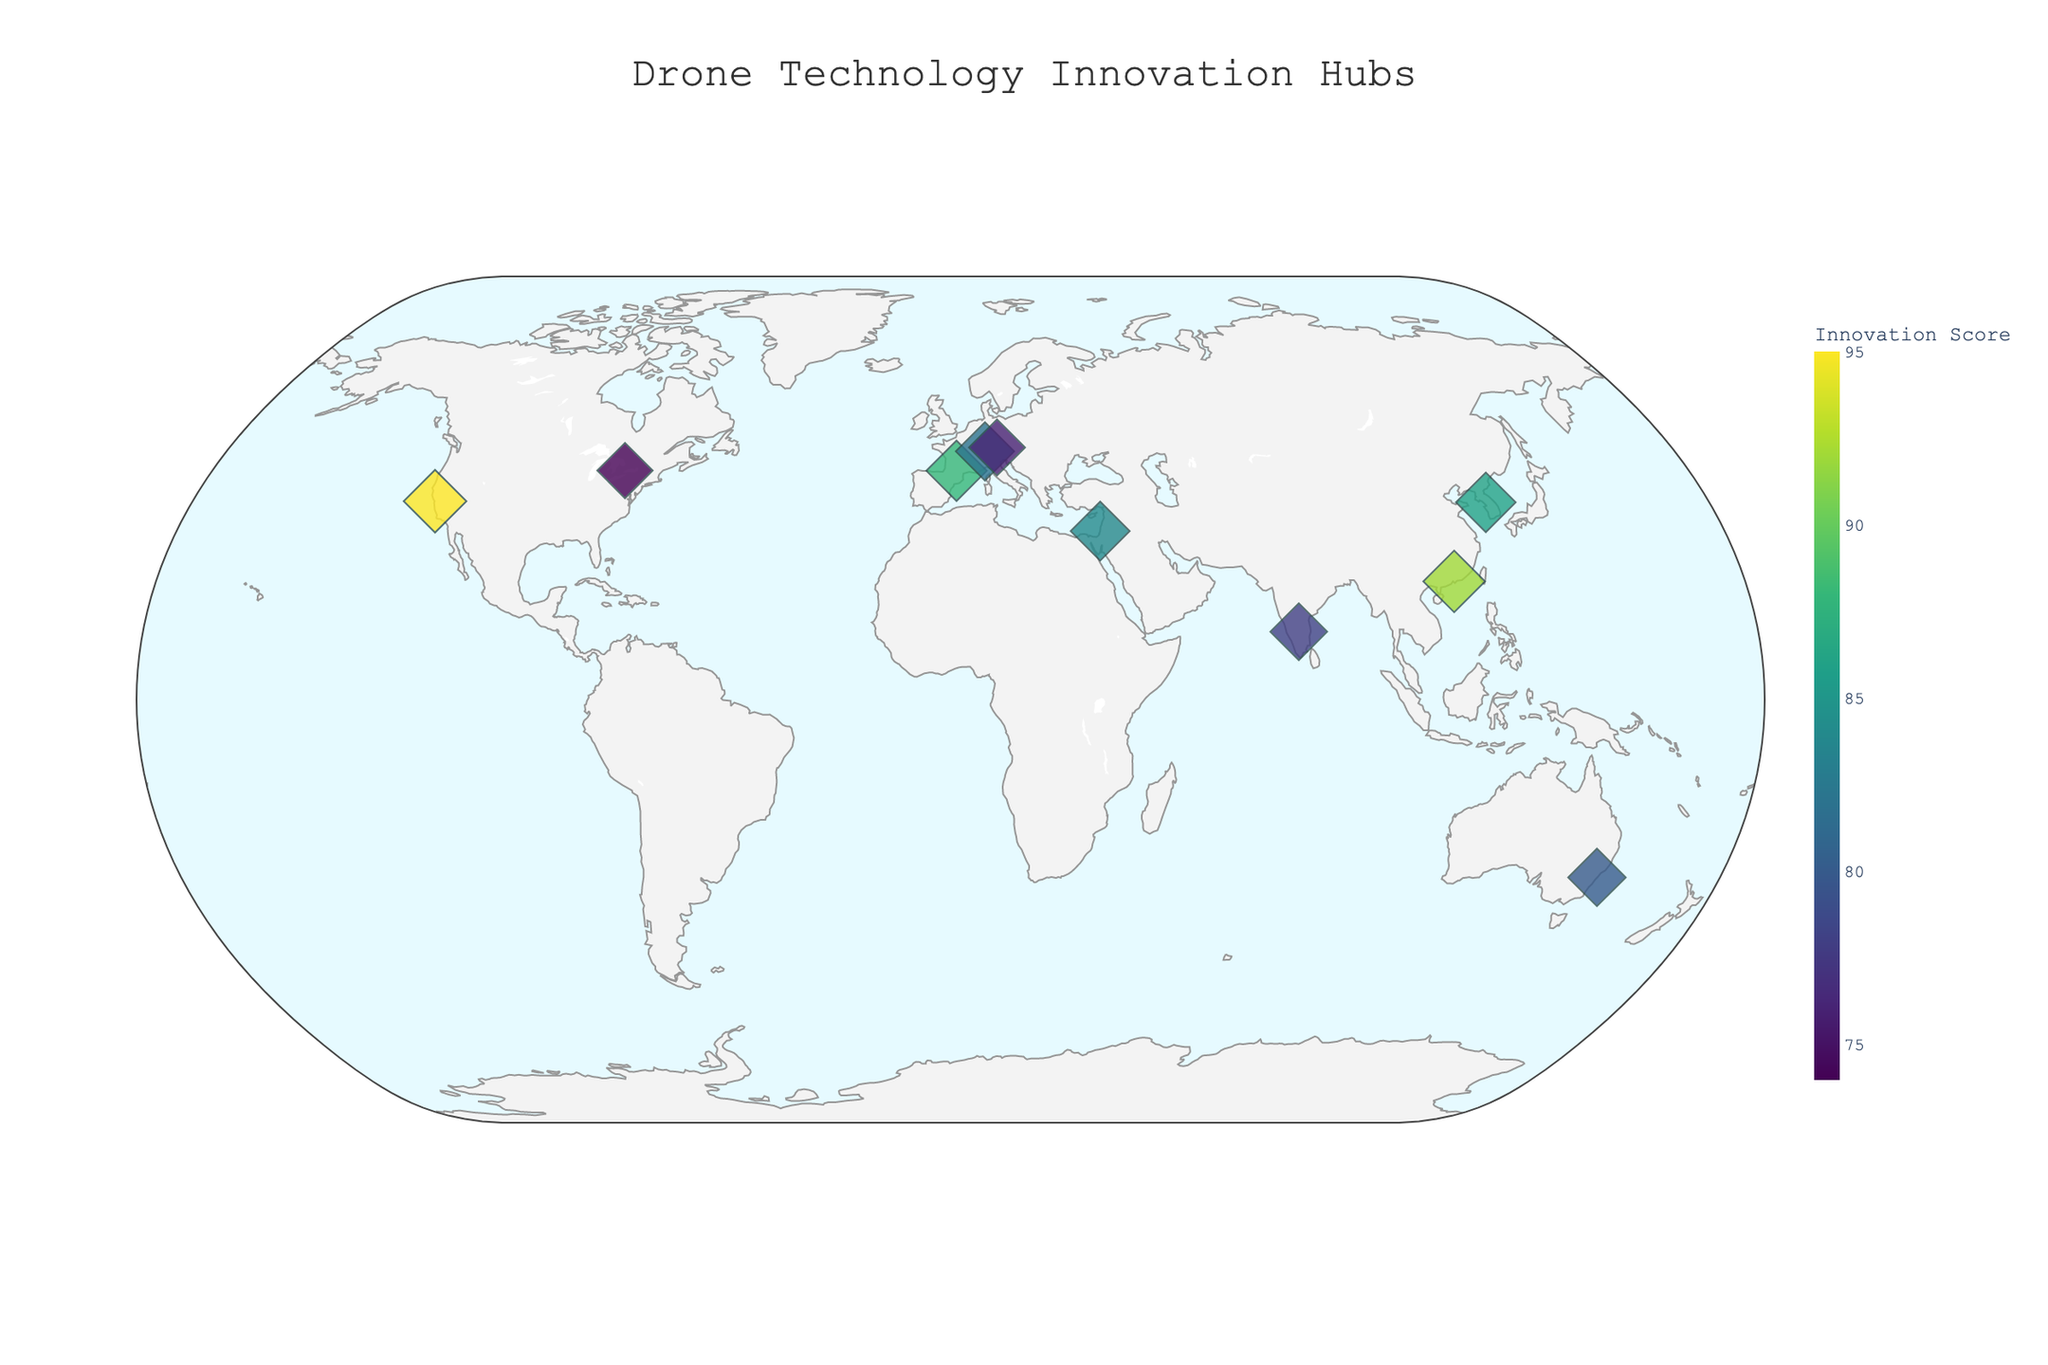How many cities are shown on the geographic plot? Count the number of unique city markers displayed on the map. Each marker represents a city. In this plot, there are markers for 10 cities.
Answer: 10 Which city has the highest Innovation Score? Identify the largest marker and look at the corresponding hover information. San Francisco has the largest marker with an Innovation Score of 95.
Answer: San Francisco What research focus is associated with the hub in Zurich? Hover over the marker for Zurich and read the displayed information. Zurich's research focus is on Obstacle avoidance algorithms.
Answer: Obstacle avoidance algorithms Compare the Innovation Scores of Seoul and Tel Aviv. Which one is higher? Locate the markers for Seoul and Tel Aviv by their coordinates, then compare their Innovation Scores. Seoul has a score of 86, and Tel Aviv has a score of 84. Hence, Seoul has the higher score.
Answer: Seoul What are the northernmost and southernmost cities shown in the plot? Examine the latitude values of all the cities. The northernmost city is Zurich (47.3769), and the southernmost city is Sydney (-33.8688).
Answer: Zurich (northernmost), Sydney (southernmost) Which city focuses on Autonomous navigation systems? Hover over the markers to find the city with the research focus on Autonomous navigation systems. Toulouse has this research focus.
Answer: Toulouse What is the average Innovation Score of the cities listed on the plot? Sum all the Innovation Scores and divide by the number of cities. The total is 835, and there are 10 cities, so the average score is 835/10.
Answer: 83.5 Which city is located most closely to 40° latitude? Compare the absolute differences between the cities’ latitudes and 40°. The city closest to this latitude is Toulouse (43.6047).
Answer: Toulouse Identify all the cities with an Innovation Score greater than 80. Look for markers where the Innovation Score is indicated as above 80. The cities are San Francisco, Shenzhen, Toulouse, and Seoul.
Answer: San Francisco, Shenzhen, Toulouse, Seoul What city is shown farthest east on the map? Examine the longitude values. The city with the highest longitude value is determined to be Shenzhen (114.0579).
Answer: Shenzhen 